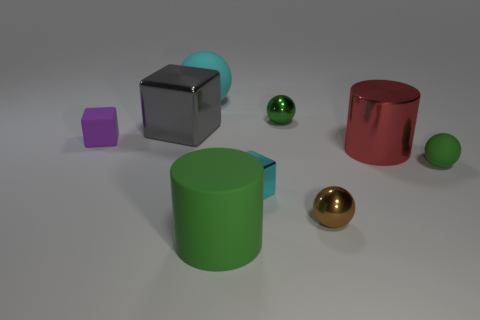Subtract all cubes. How many objects are left? 6 Subtract 1 cyan blocks. How many objects are left? 8 Subtract all red metal cylinders. Subtract all big metallic cylinders. How many objects are left? 7 Add 6 large gray cubes. How many large gray cubes are left? 7 Add 3 tiny cyan objects. How many tiny cyan objects exist? 4 